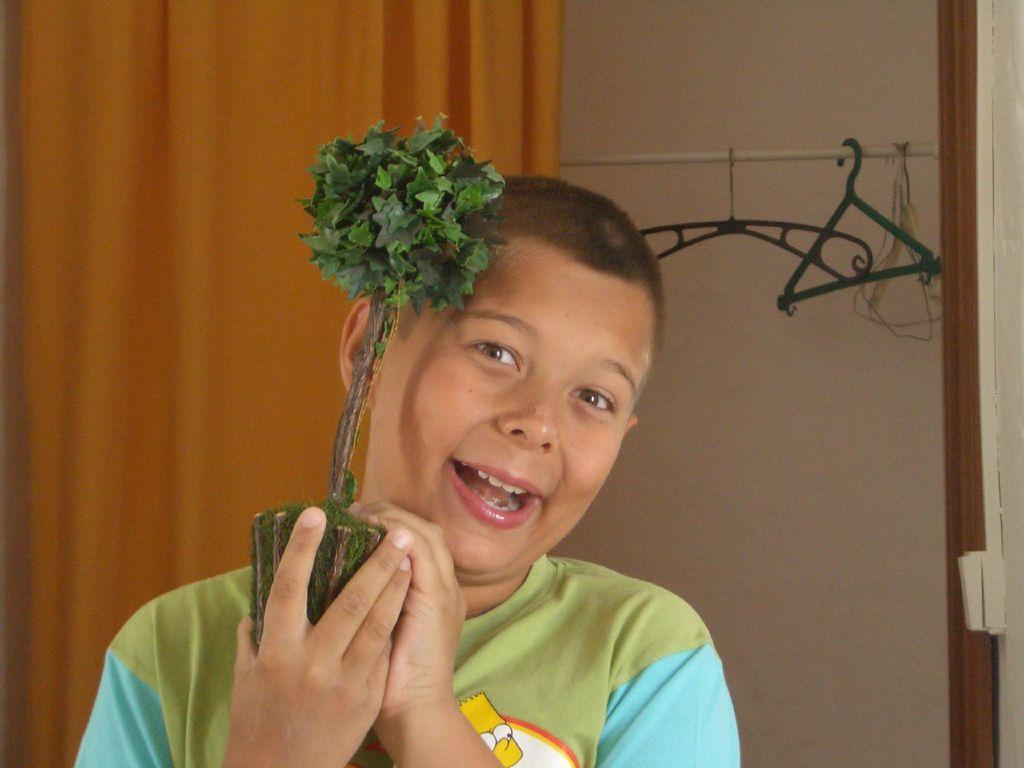How would you summarize this image in a sentence or two? In this image I can see the person holding the plant and the person is wearing blue and green color dress. In the background I can see few hangers and they are hanged to the pole and I can see few curtains and the wall is in cream color. 